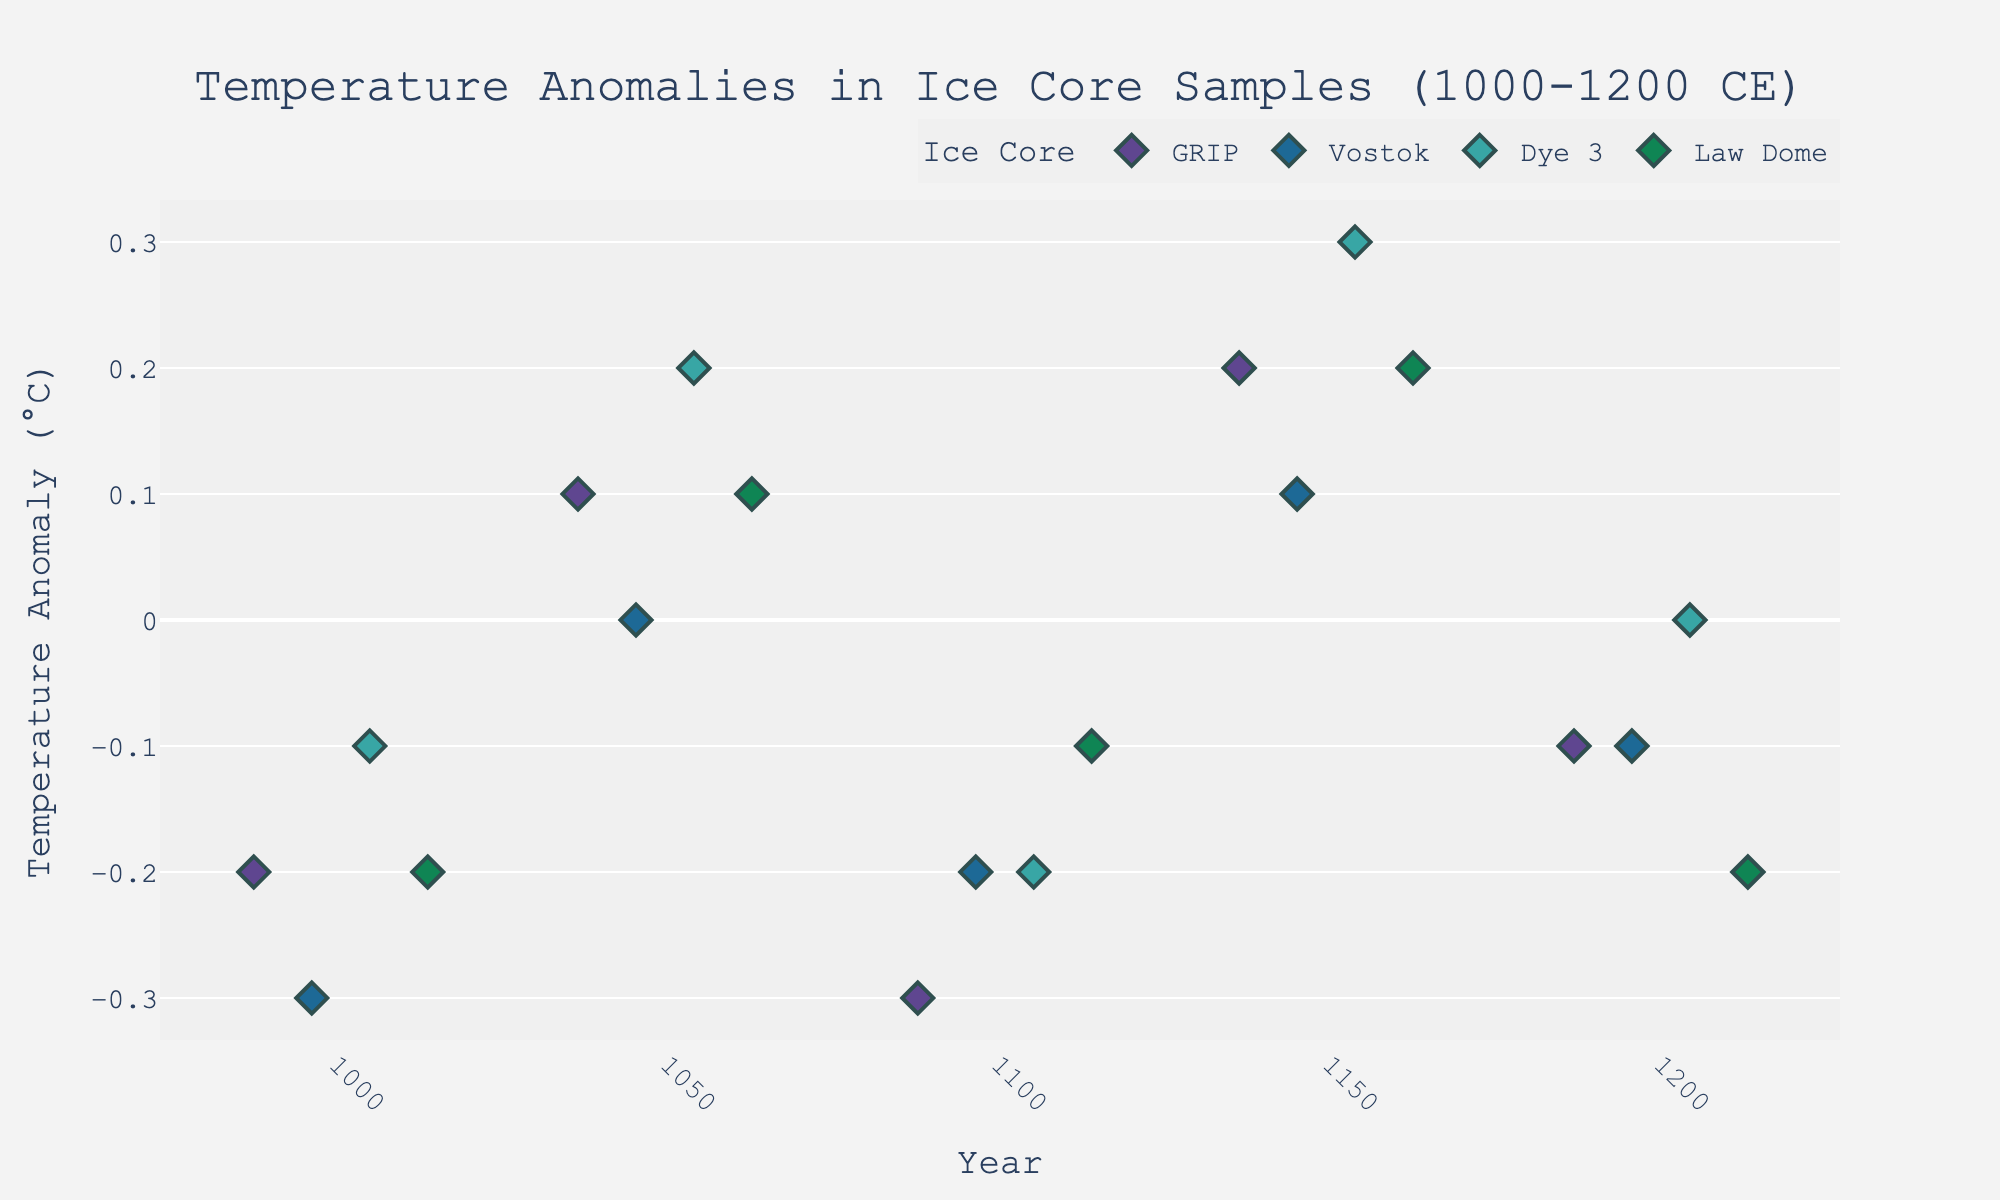What is the title of the figure? Look at the top of the plot where the title is displayed. The title gives a summary of what the figure is about.
Answer: "Temperature Anomalies in Ice Core Samples (1000-1200 CE)" What years are represented on the X-axis? The X-axis represents the years for which the temperature anomalies are recorded. You can see these years along the bottom of the plot.
Answer: 1000, 1050, 1100, 1150, 1200 How many different ice cores are represented in the figure? The different ice cores are indicated by colors and are listed in the legend. Count the number of unique labels to determine the total number of different ice cores.
Answer: 4 Which ice core shows the highest temperature anomaly? Look at the data points on the Y-axis to identify the highest anomaly. Check which ice core's data point is associated with this anomaly.
Answer: Dye 3 What's the average temperature anomaly for the GRIP ice core? Locate all the data points for the GRIP ice core and note their values. Calculate their average. Values: -0.2, 0.1, -0.3, 0.2, -0.1. Sum: -0.2 + 0.1 - 0.3 + 0.2 - 0.1 = -0.3. Average: -0.3 / 5 = -0.06
Answer: -0.06 Which year shows the highest positive temperature anomaly across all ice cores? Identify the year where the highest positive data point is located across all the ice cores on the Y-axis. This is the highest temperature point.
Answer: 1150 What is the range of temperature anomalies recorded for the Vostok ice core? Identify the maximum and minimum values of the temperature anomalies for Vostok and calculate their difference. Vostok anomalies: -0.3 to 0.1. Range: 0.1 - (-0.3) = 0.4
Answer: 0.4 Are there any years where all ice cores have negative temperature anomalies? If so, which? Check each year on the X-axis and see if all data points in that year are below zero.
Answer: No Which ice core shows more variability in its temperature anomalies, GRIP or Law Dome? Calculate the range (maximum - minimum) of anomalies for both ice cores and compare. GRIP: -0.3 to 0.2 (Range: 0.5), Law Dome: -0.2 to 0.2 (Range: 0.4).
Answer: GRIP Did any ice core show consistent warming (continuous positive anomalies) during the observed period? Check each ice core's data points to see if any have all positive values for all years. None of the ice cores have all positive anomalies.
Answer: No 